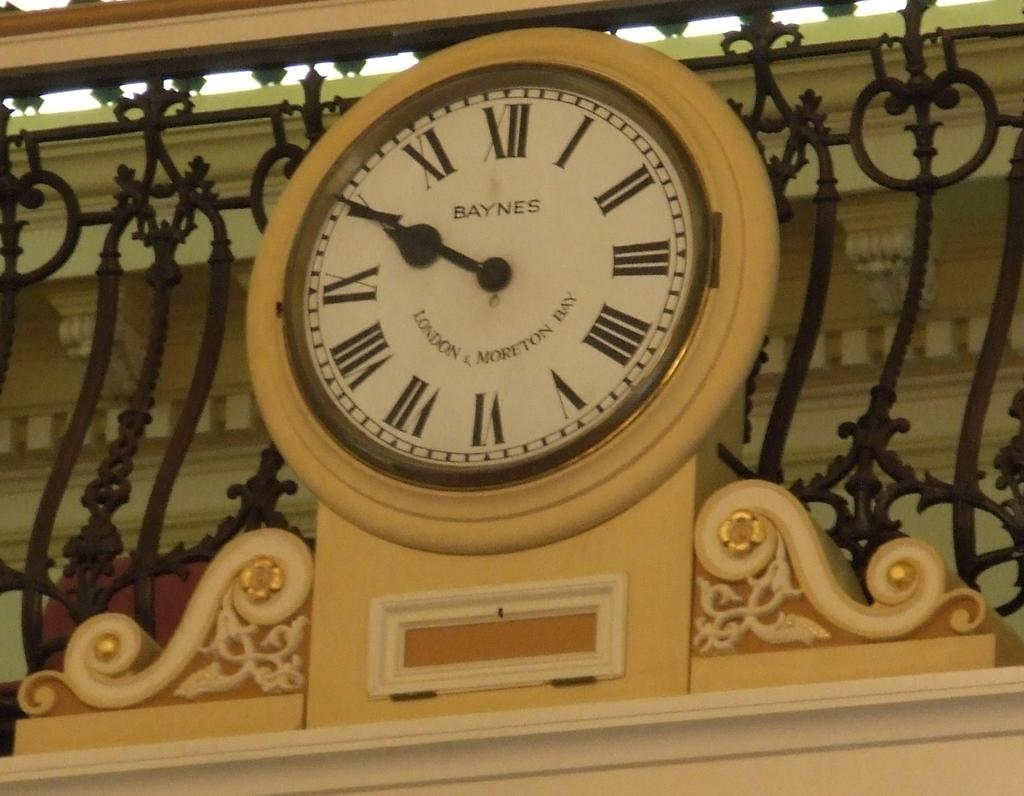<image>
Share a concise interpretation of the image provided. White clock with roman numerals and the word "LONDON" on it. 